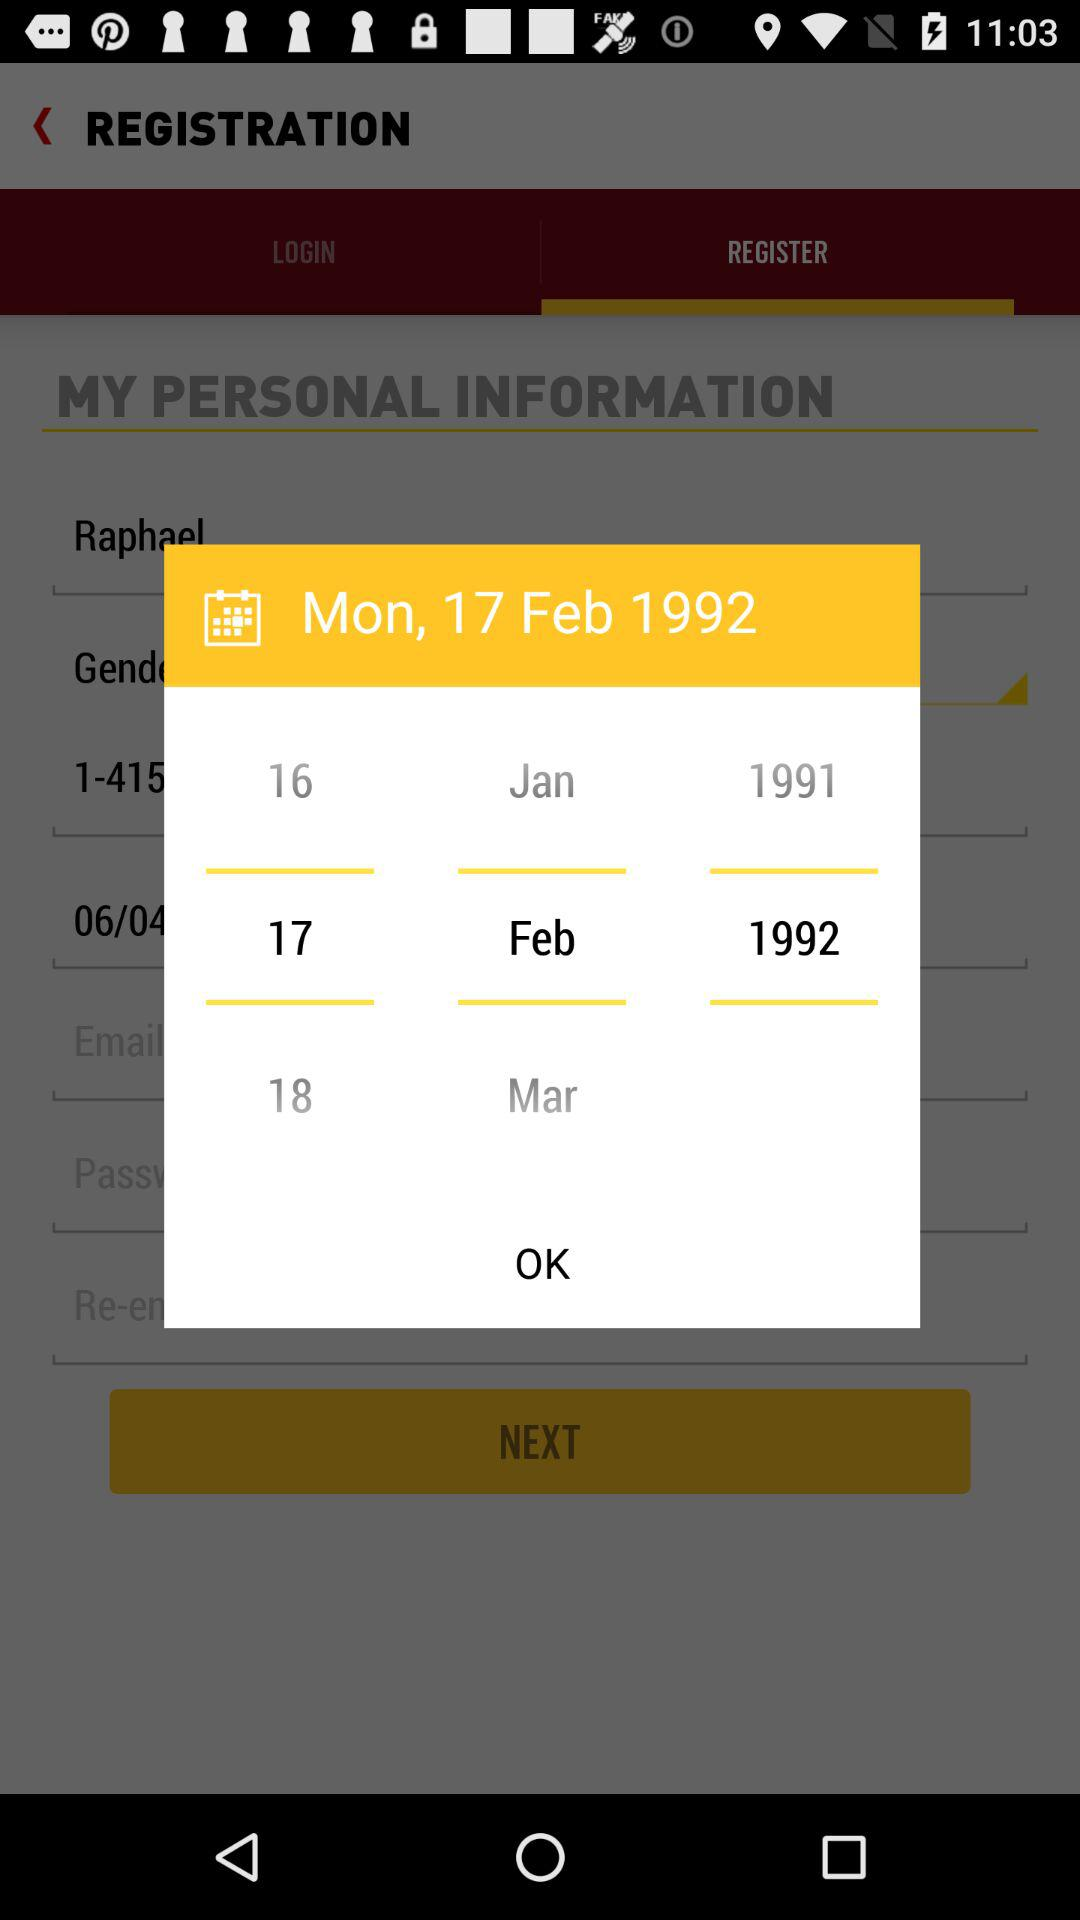How many months are shown?
Answer the question using a single word or phrase. 3 